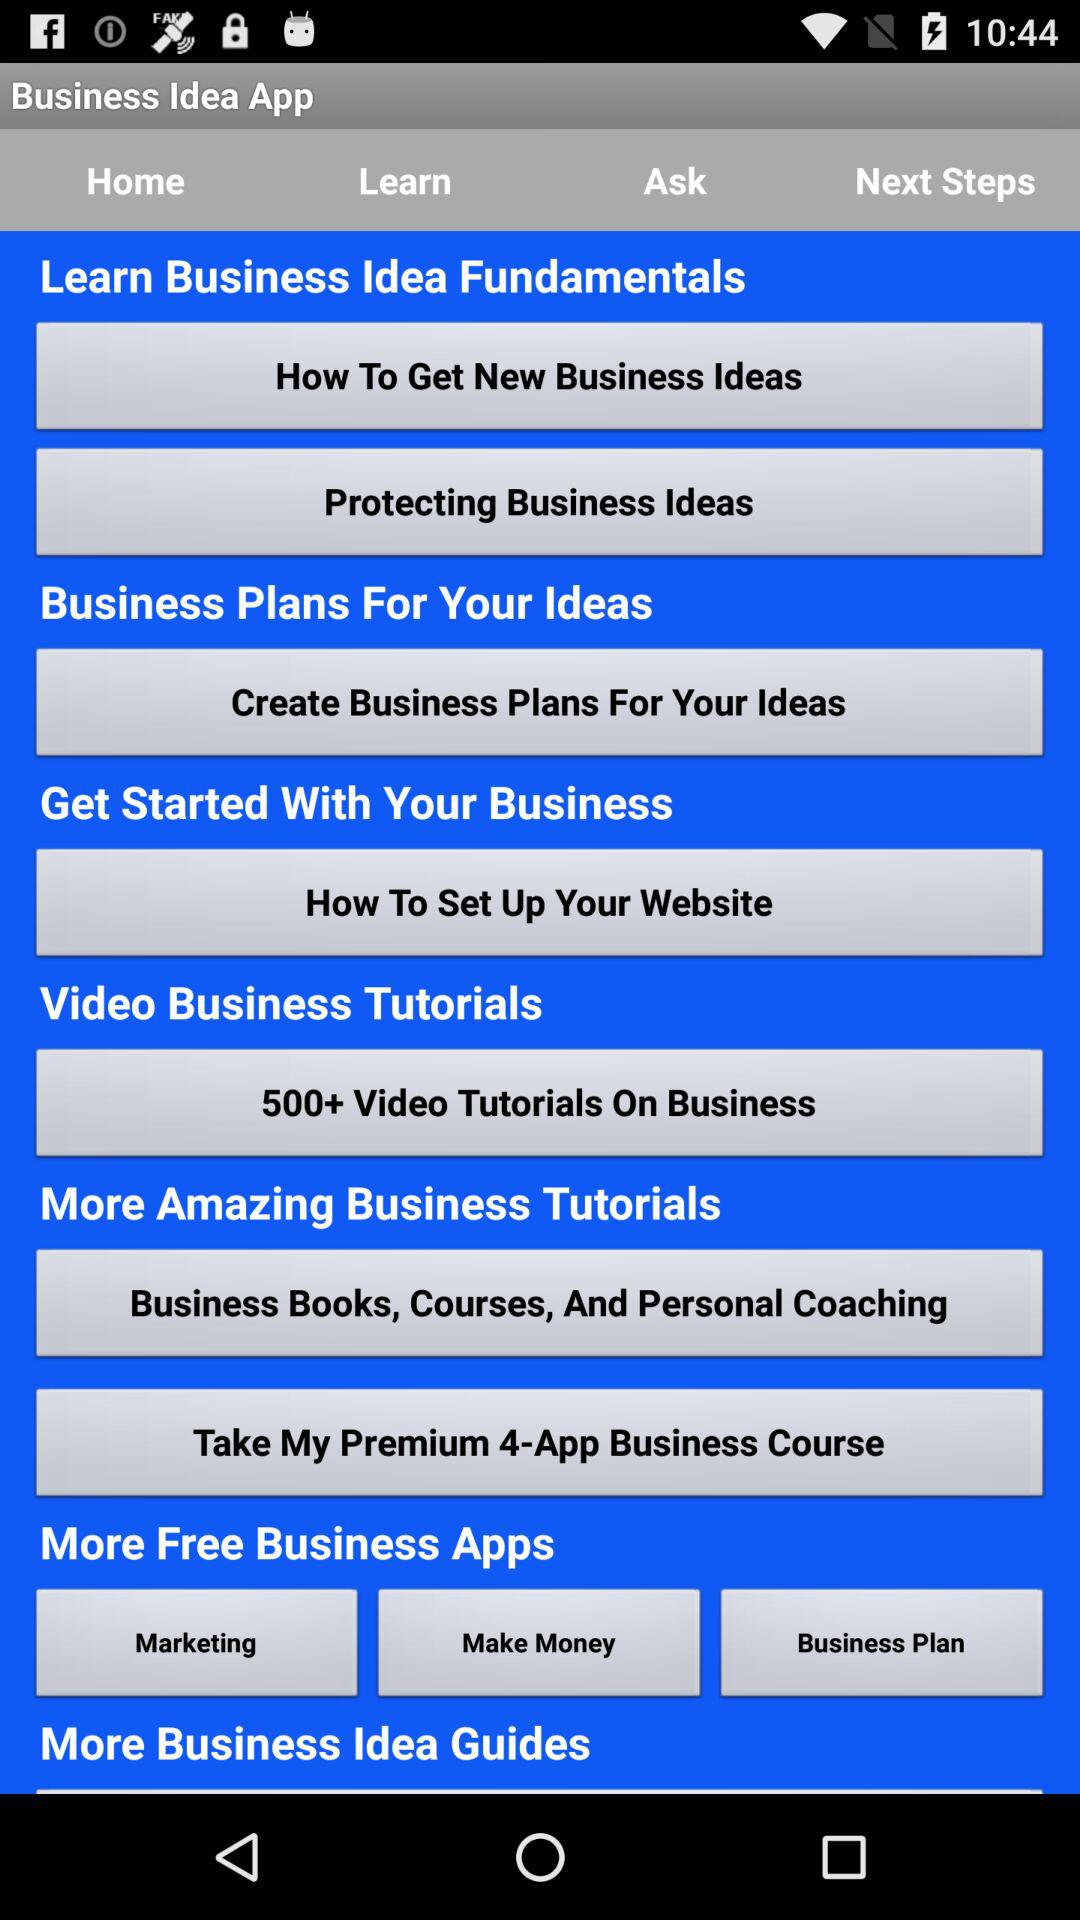What is the mentioned number of videos for business tutorials? There are more than 500 videos for business tutorials. 